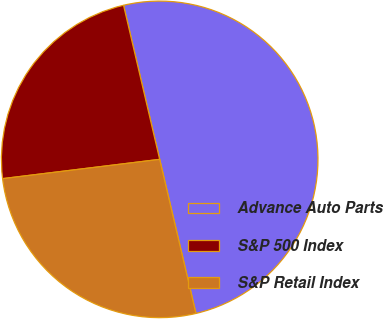<chart> <loc_0><loc_0><loc_500><loc_500><pie_chart><fcel>Advance Auto Parts<fcel>S&P 500 Index<fcel>S&P Retail Index<nl><fcel>49.99%<fcel>23.28%<fcel>26.74%<nl></chart> 